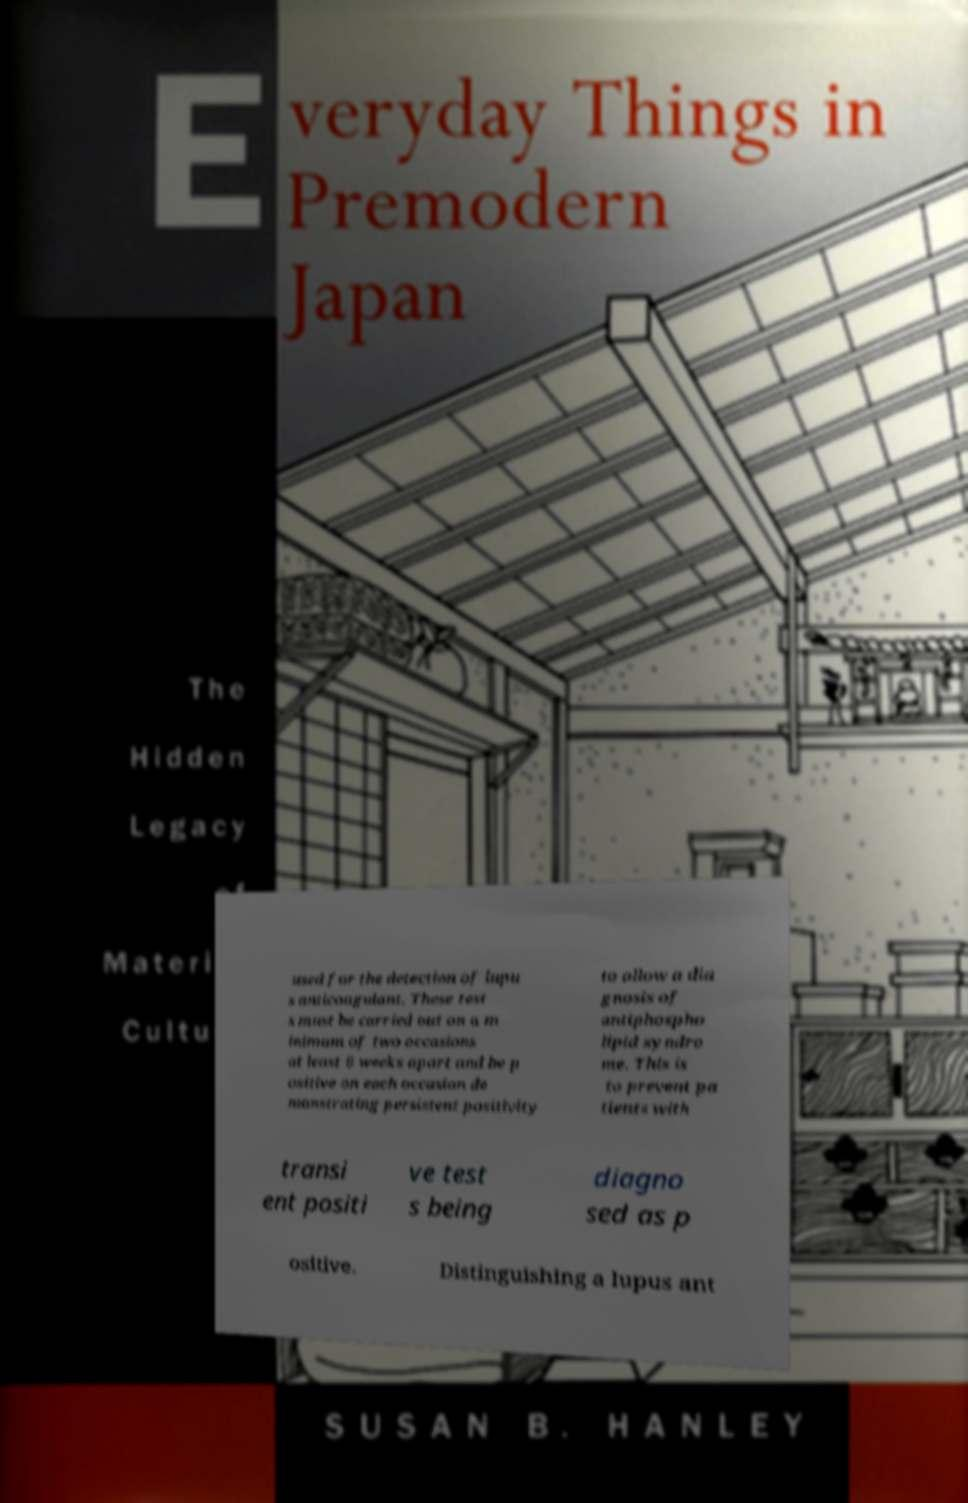Please identify and transcribe the text found in this image. used for the detection of lupu s anticoagulant. These test s must be carried out on a m inimum of two occasions at least 6 weeks apart and be p ositive on each occasion de monstrating persistent positivity to allow a dia gnosis of antiphospho lipid syndro me. This is to prevent pa tients with transi ent positi ve test s being diagno sed as p ositive. Distinguishing a lupus ant 